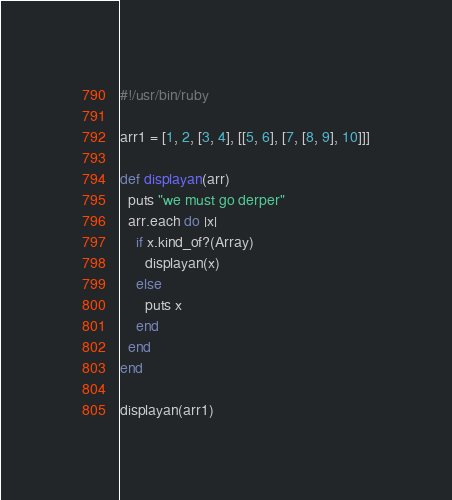<code> <loc_0><loc_0><loc_500><loc_500><_Ruby_>#!/usr/bin/ruby

arr1 = [1, 2, [3, 4], [[5, 6], [7, [8, 9], 10]]]

def displayan(arr)
  puts "we must go derper"
  arr.each do |x|    
    if x.kind_of?(Array)
      displayan(x)
    else
      puts x
    end
  end
end

displayan(arr1)
</code> 